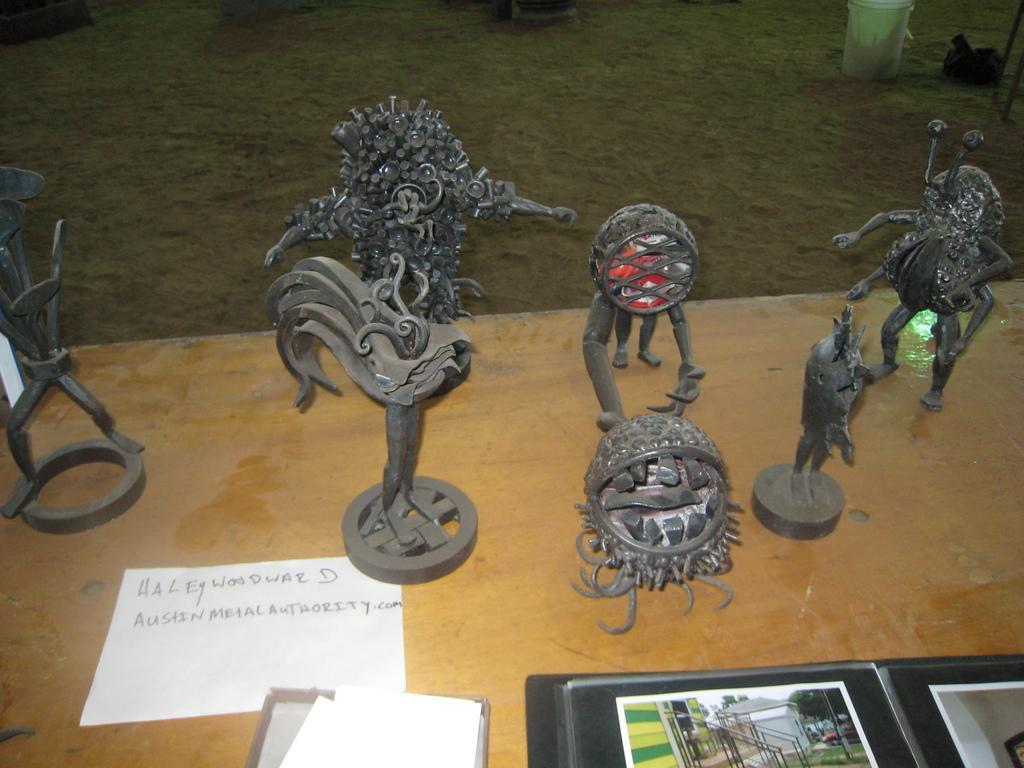In one or two sentences, can you explain what this image depicts? In this image I can see few black color statues,papers and file on the brown color table. Back I can see white and black color objects are on the ground. 